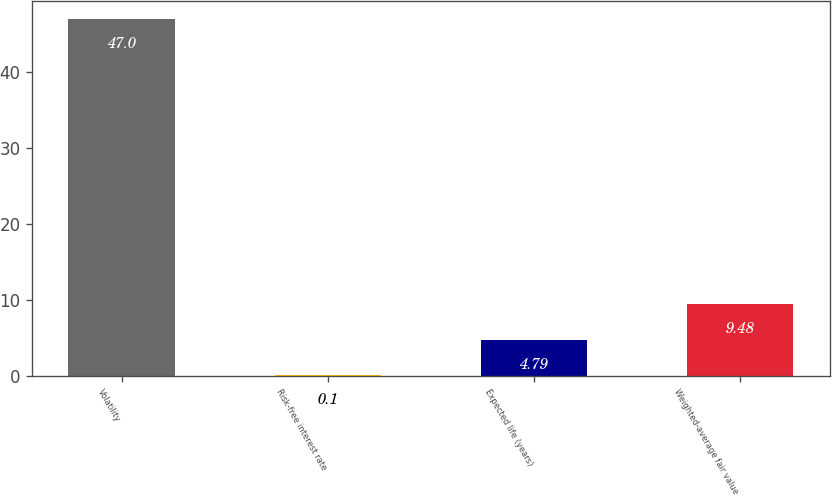Convert chart. <chart><loc_0><loc_0><loc_500><loc_500><bar_chart><fcel>Volatility<fcel>Risk-free interest rate<fcel>Expected life (years)<fcel>Weighted-average fair value<nl><fcel>47<fcel>0.1<fcel>4.79<fcel>9.48<nl></chart> 